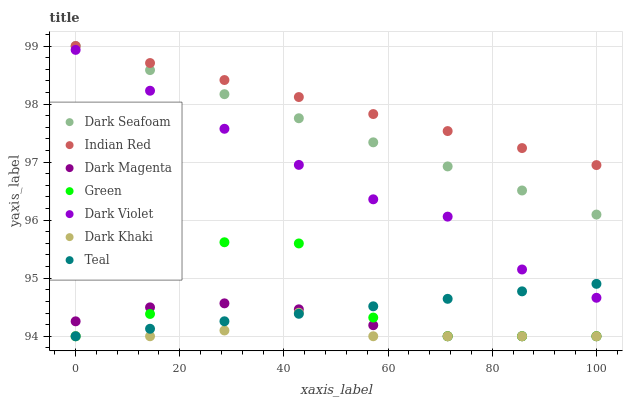Does Dark Khaki have the minimum area under the curve?
Answer yes or no. Yes. Does Indian Red have the maximum area under the curve?
Answer yes or no. Yes. Does Dark Magenta have the minimum area under the curve?
Answer yes or no. No. Does Dark Magenta have the maximum area under the curve?
Answer yes or no. No. Is Teal the smoothest?
Answer yes or no. Yes. Is Green the roughest?
Answer yes or no. Yes. Is Dark Magenta the smoothest?
Answer yes or no. No. Is Dark Magenta the roughest?
Answer yes or no. No. Does Teal have the lowest value?
Answer yes or no. Yes. Does Dark Violet have the lowest value?
Answer yes or no. No. Does Indian Red have the highest value?
Answer yes or no. Yes. Does Dark Magenta have the highest value?
Answer yes or no. No. Is Green less than Dark Seafoam?
Answer yes or no. Yes. Is Dark Seafoam greater than Teal?
Answer yes or no. Yes. Does Dark Khaki intersect Teal?
Answer yes or no. Yes. Is Dark Khaki less than Teal?
Answer yes or no. No. Is Dark Khaki greater than Teal?
Answer yes or no. No. Does Green intersect Dark Seafoam?
Answer yes or no. No. 